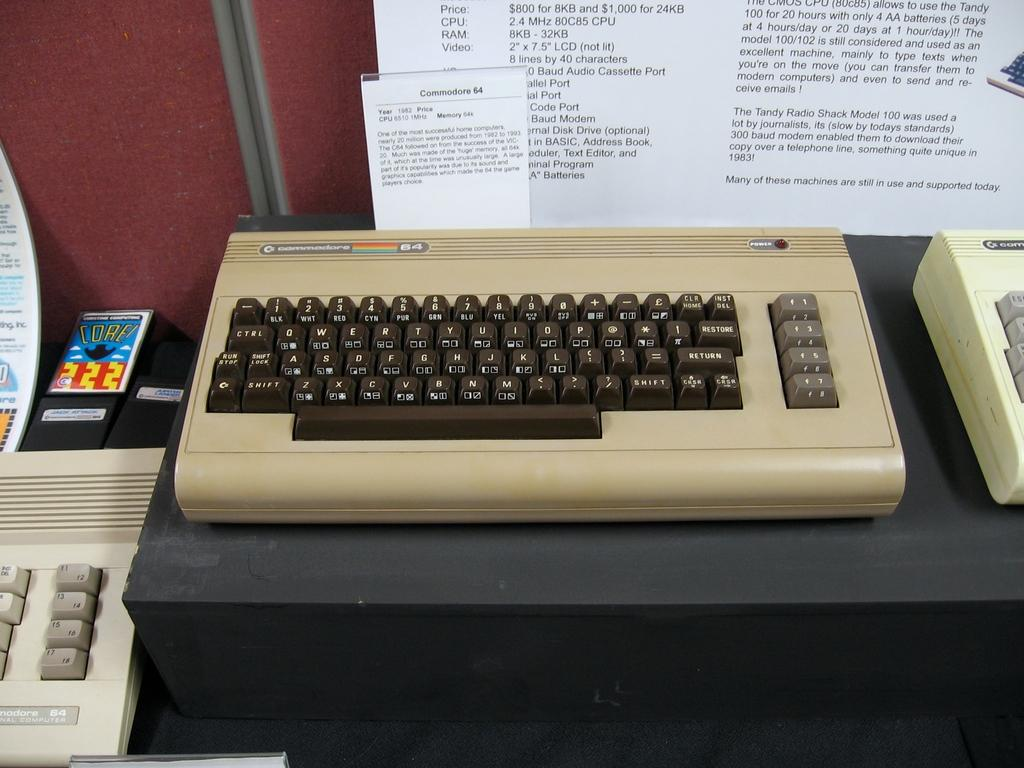<image>
Summarize the visual content of the image. On a black surface sits an antique Commodore 64 keyboard with an informative white sign behind it containing the year it came out and a brief description of the item. 